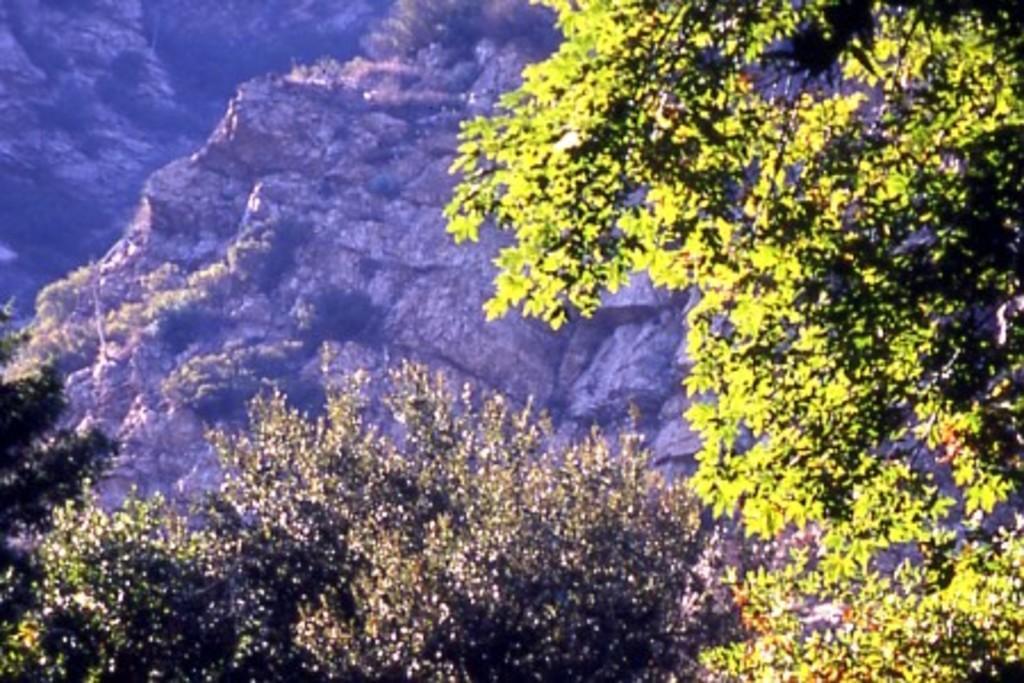Could you give a brief overview of what you see in this image? This picture shows few trees and hills. 